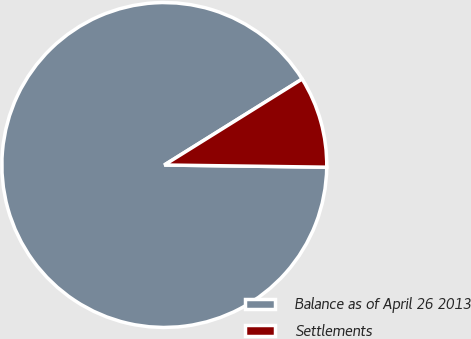<chart> <loc_0><loc_0><loc_500><loc_500><pie_chart><fcel>Balance as of April 26 2013<fcel>Settlements<nl><fcel>90.91%<fcel>9.09%<nl></chart> 